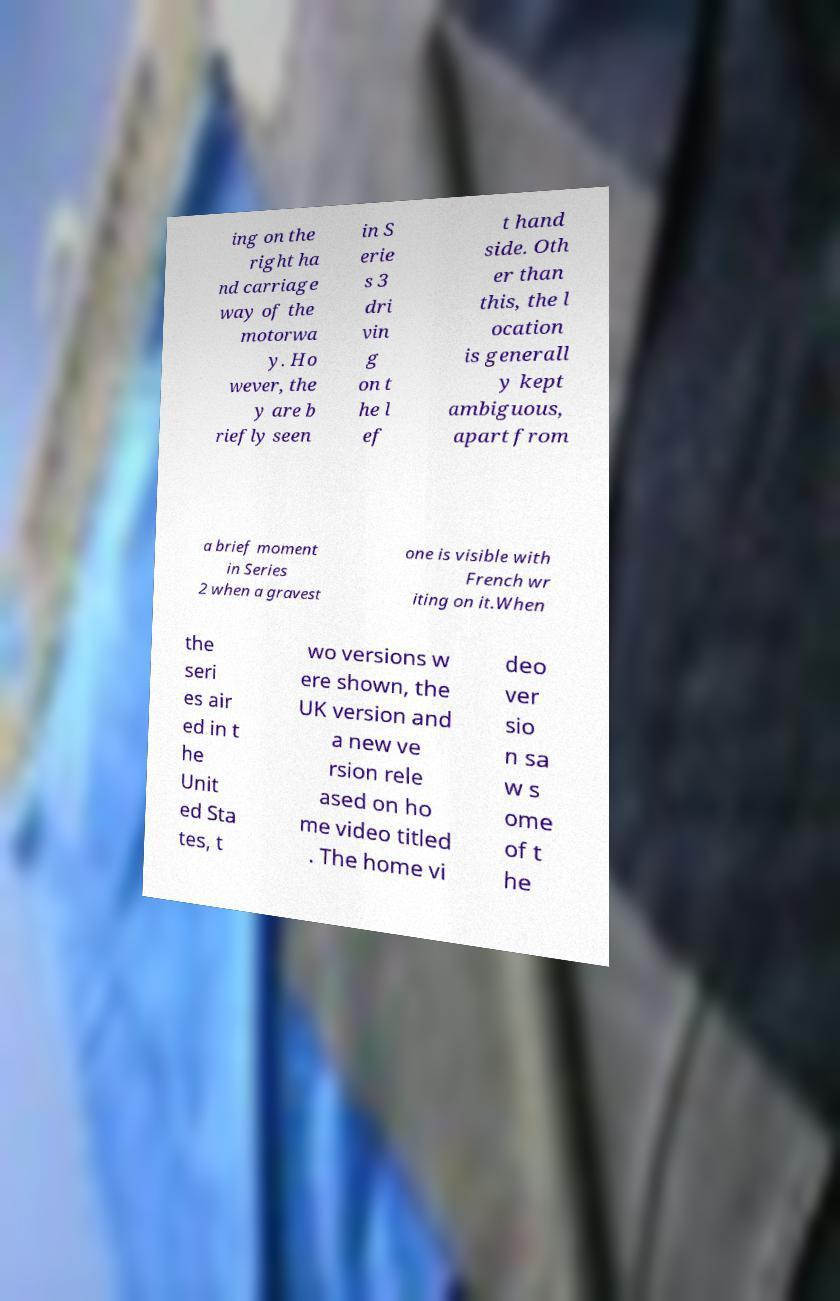Could you assist in decoding the text presented in this image and type it out clearly? ing on the right ha nd carriage way of the motorwa y. Ho wever, the y are b riefly seen in S erie s 3 dri vin g on t he l ef t hand side. Oth er than this, the l ocation is generall y kept ambiguous, apart from a brief moment in Series 2 when a gravest one is visible with French wr iting on it.When the seri es air ed in t he Unit ed Sta tes, t wo versions w ere shown, the UK version and a new ve rsion rele ased on ho me video titled . The home vi deo ver sio n sa w s ome of t he 